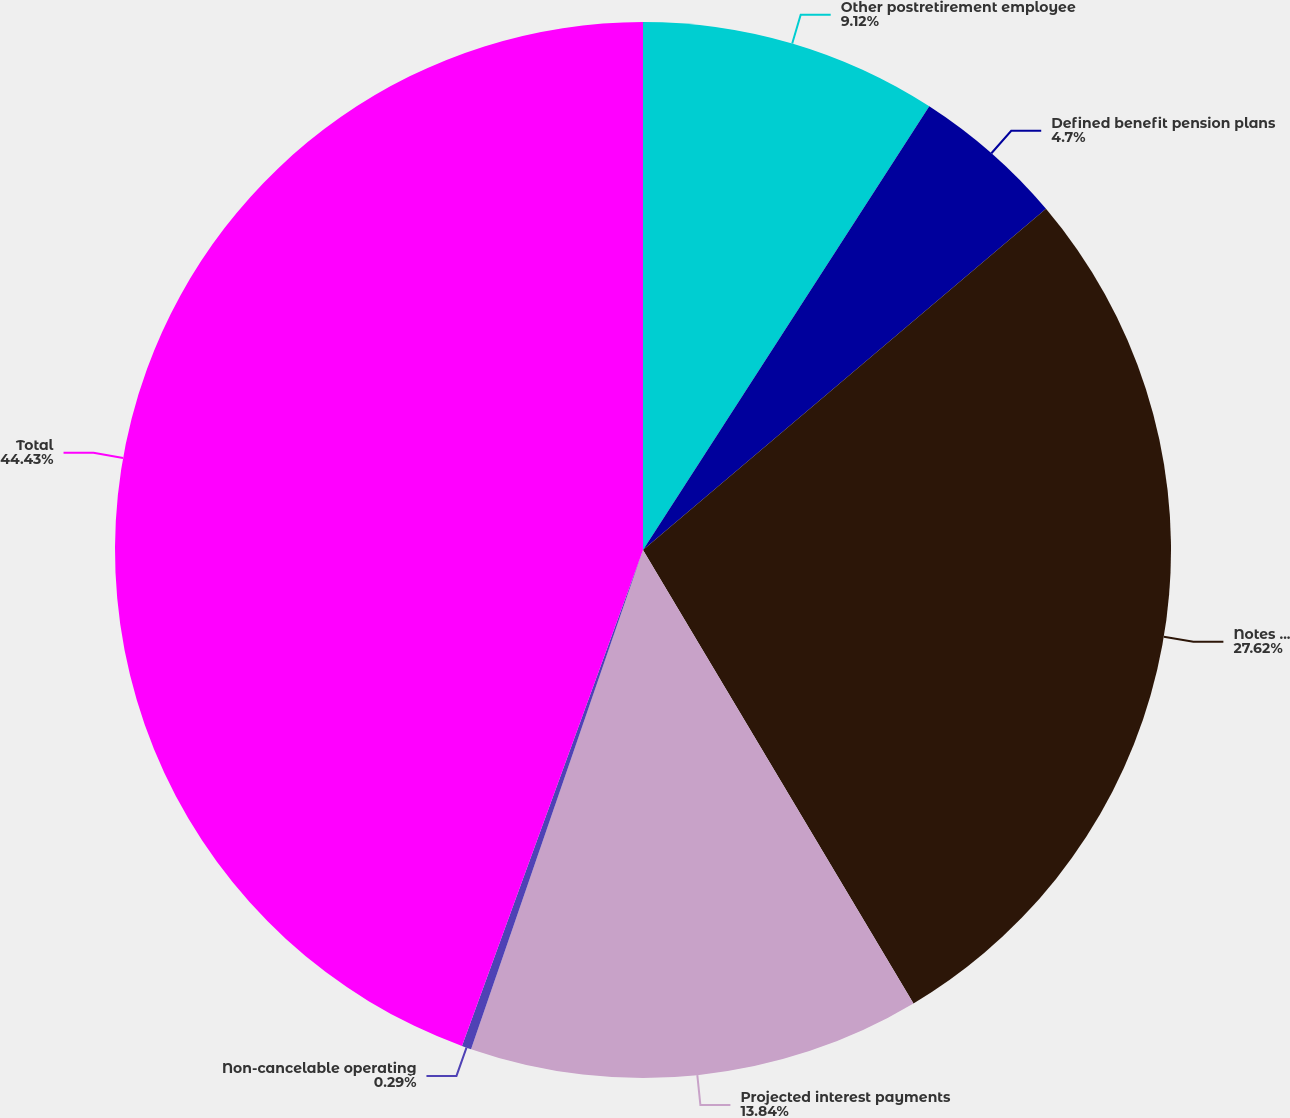<chart> <loc_0><loc_0><loc_500><loc_500><pie_chart><fcel>Other postretirement employee<fcel>Defined benefit pension plans<fcel>Notes payable and long-term<fcel>Projected interest payments<fcel>Non-cancelable operating<fcel>Total<nl><fcel>9.12%<fcel>4.7%<fcel>27.62%<fcel>13.84%<fcel>0.29%<fcel>44.43%<nl></chart> 